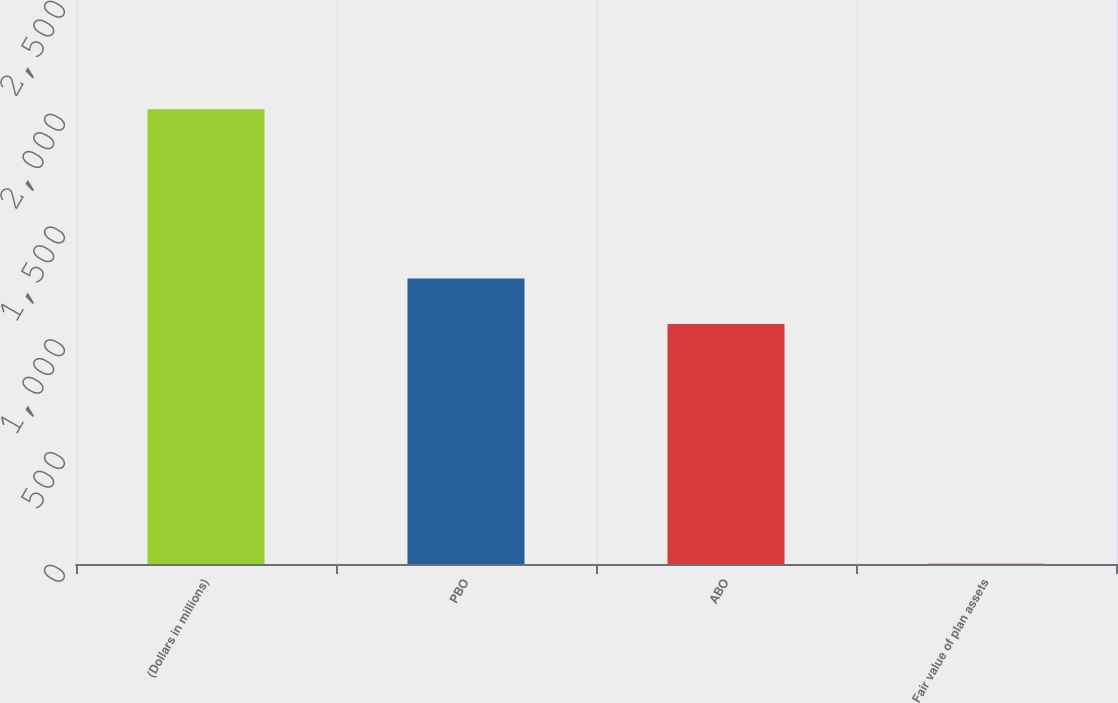Convert chart. <chart><loc_0><loc_0><loc_500><loc_500><bar_chart><fcel>(Dollars in millions)<fcel>PBO<fcel>ABO<fcel>Fair value of plan assets<nl><fcel>2016<fcel>1265.5<fcel>1064<fcel>1<nl></chart> 